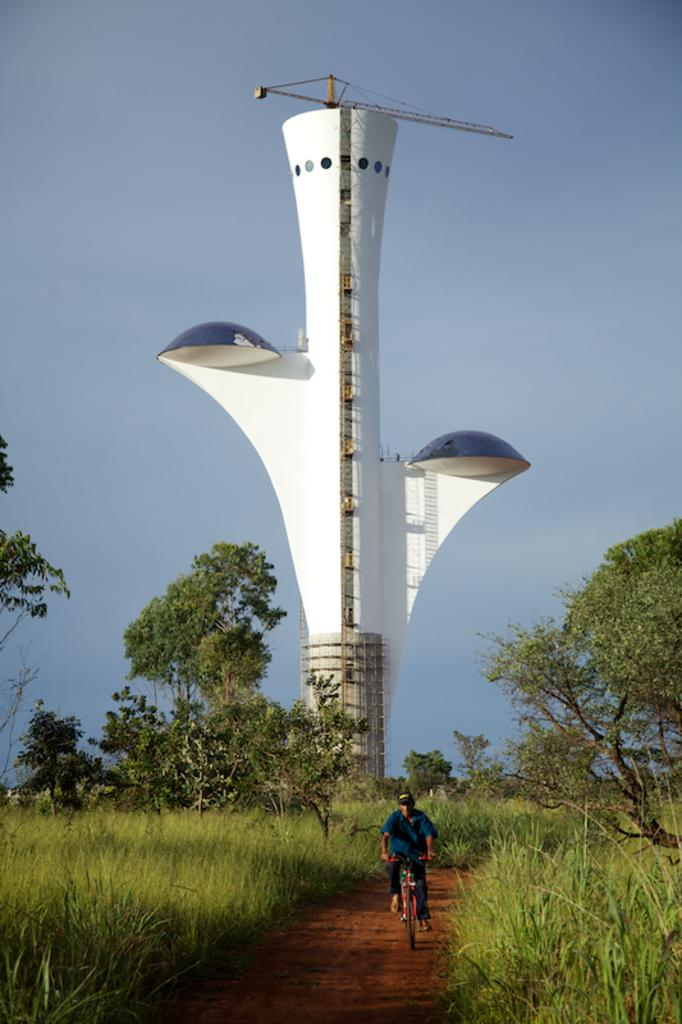Who is the main subject in the image? There is a man in the image. What is the man doing in the image? The man is riding a bicycle. What type of terrain is visible in the image? There is grass in the image. What other natural elements can be seen in the image? There are trees in the image. What is visible at the top of the image? The sky is visible at the top of the image. What type of manager can be seen in the image? There is no manager present in the image; it features a man riding a bicycle. What type of planes are flying in the image? There are no planes visible in the image; it features a man riding a bicycle in a natural setting. 